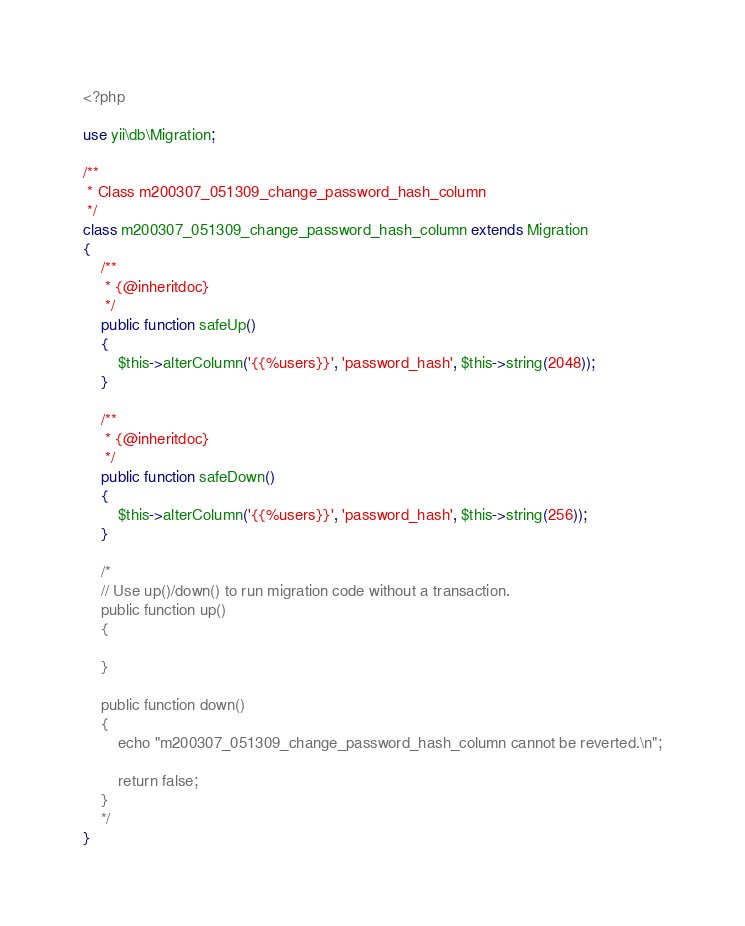Convert code to text. <code><loc_0><loc_0><loc_500><loc_500><_PHP_><?php

use yii\db\Migration;

/**
 * Class m200307_051309_change_password_hash_column
 */
class m200307_051309_change_password_hash_column extends Migration
{
    /**
     * {@inheritdoc}
     */
    public function safeUp()
    {
        $this->alterColumn('{{%users}}', 'password_hash', $this->string(2048));
    }

    /**
     * {@inheritdoc}
     */
    public function safeDown()
    {
        $this->alterColumn('{{%users}}', 'password_hash', $this->string(256));
    }

    /*
    // Use up()/down() to run migration code without a transaction.
    public function up()
    {

    }

    public function down()
    {
        echo "m200307_051309_change_password_hash_column cannot be reverted.\n";

        return false;
    }
    */
}
</code> 